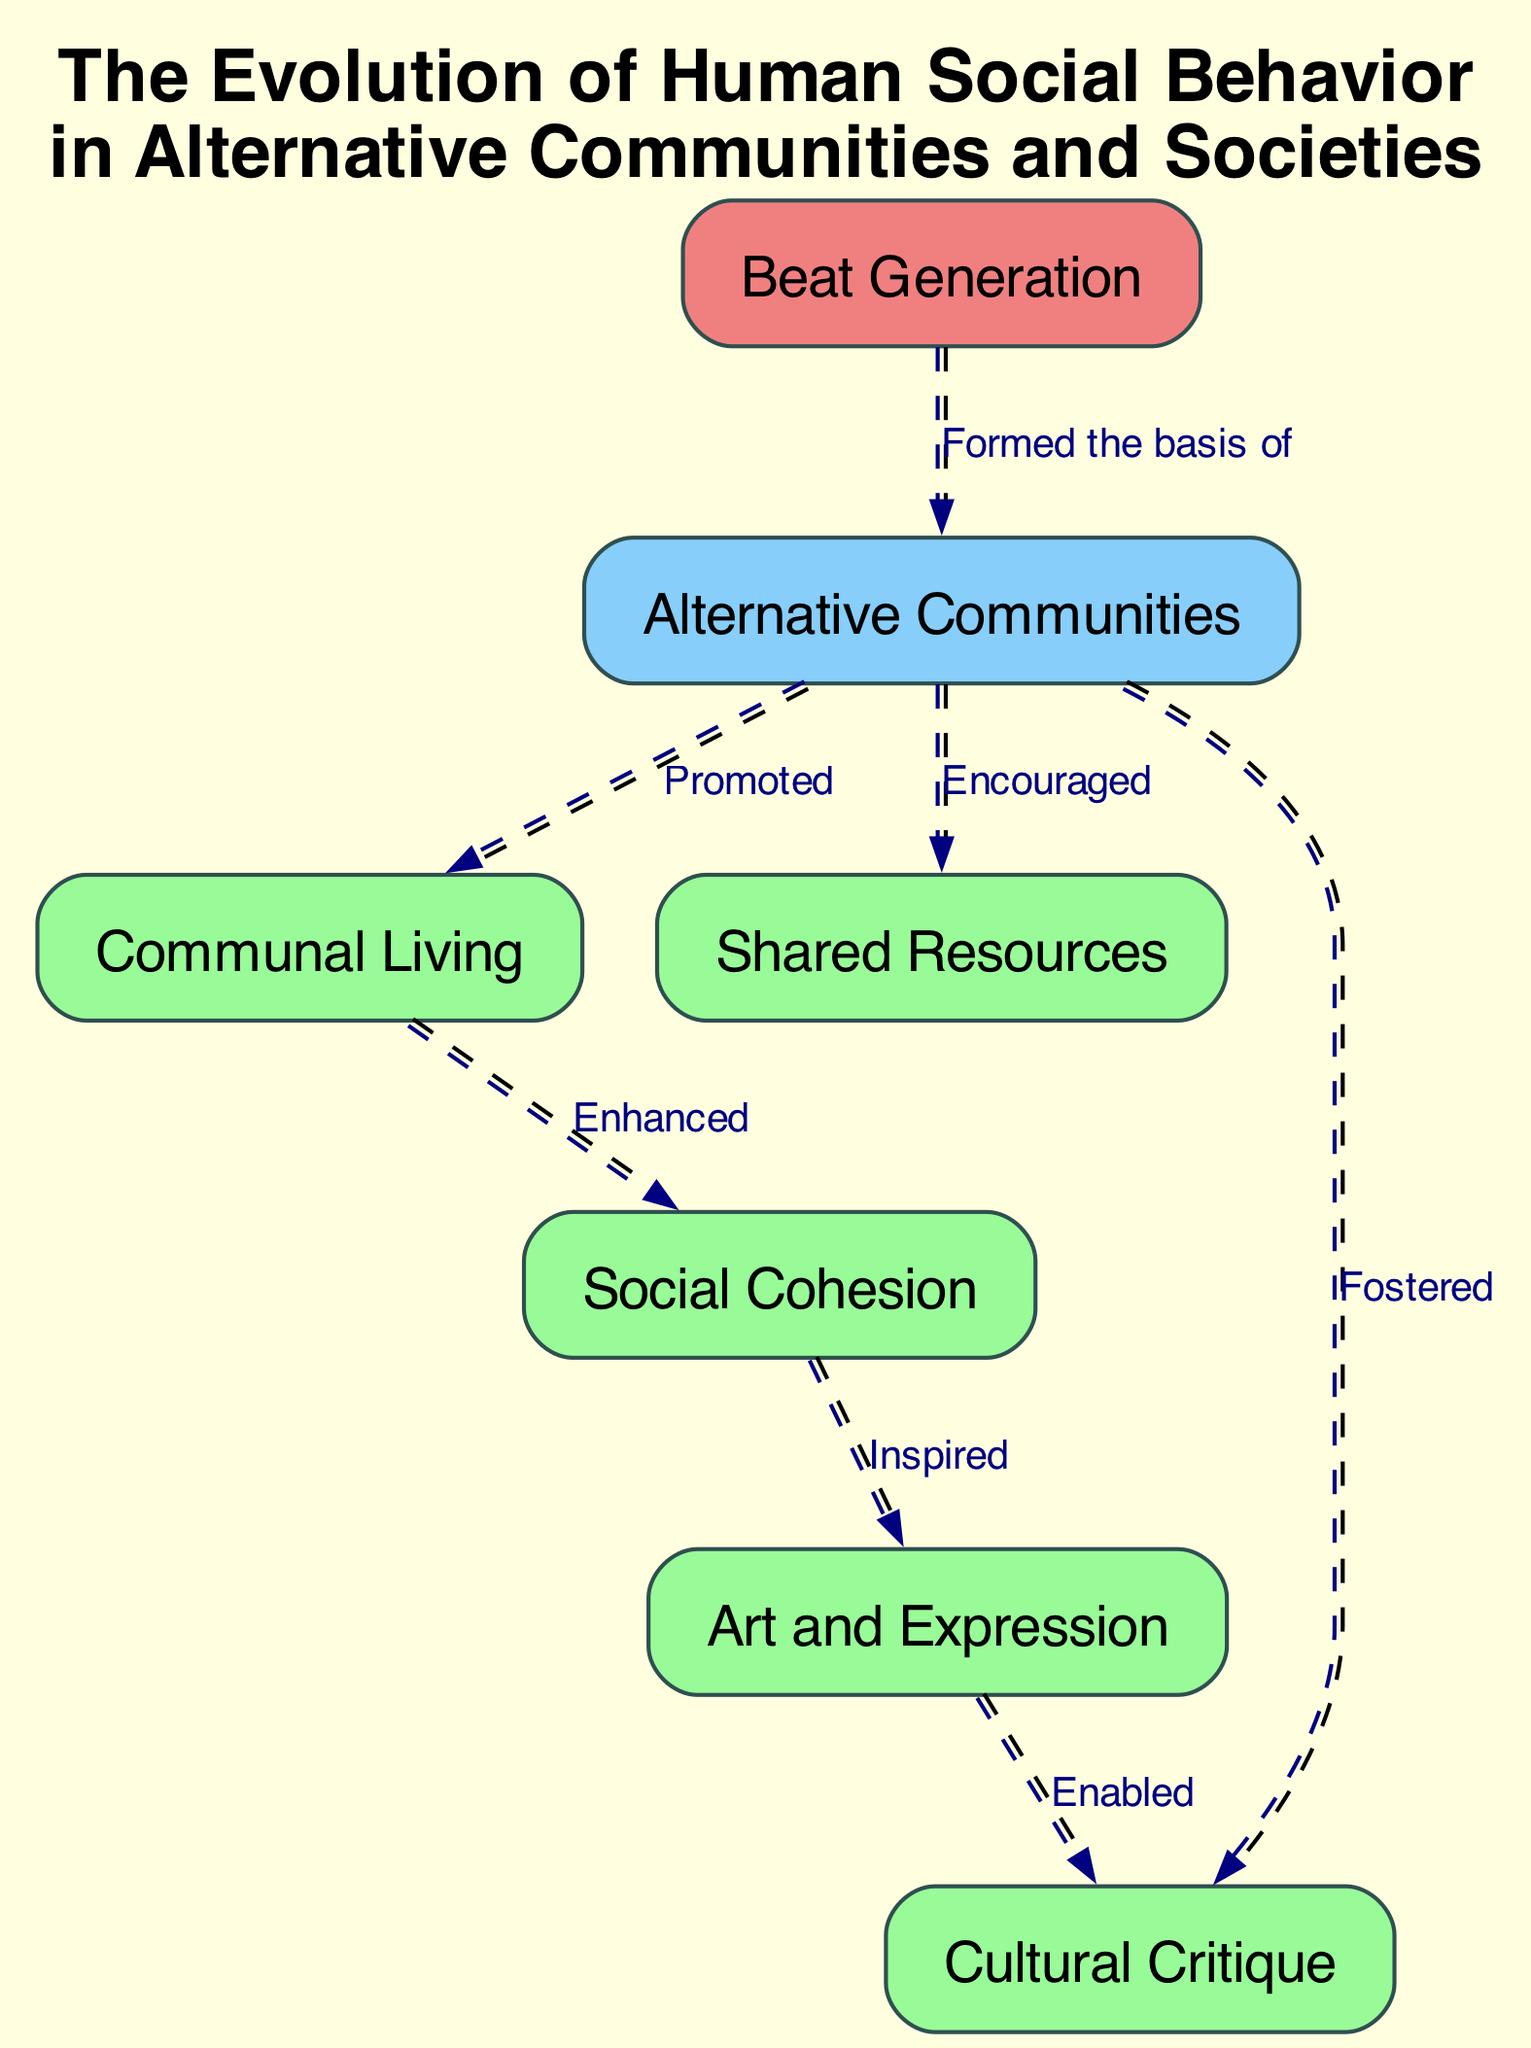What is the primary focus of the diagram? The diagram illustrates the evolution of human social behavior in alternative communities and societies, highlighting the relationships between various elements in this context.
Answer: Evolution of human social behavior How many nodes are present in the diagram? By counting each unique label represented in the diagram, we can see that there are seven distinct nodes, indicating different concepts related to the subject matter.
Answer: 7 What label is associated with the edge from "Beat Generation" to "Alternative Communities"? The edge directly linking these two nodes is labeled "Formed the basis of," indicating the foundational impact of the Beat Generation on alternative communities.
Answer: Formed the basis of What type of living is promoted by "Alternative Communities"? The diagram shows that "Alternative Communities" promotes "Communal Living," evidencing a focus on shared lifestyles and collaboration within such groups.
Answer: Communal Living Which node is enabled by "Art and Expression"? The diagram indicates that "Art and Expression" enables "Cultural Critique," suggesting a connection where artistic expression fosters critical examination of culture.
Answer: Cultural Critique How does "Communal Living" affect "Social Cohesion"? The diagram illustrates that "Communal Living" enhances "Social Cohesion," which reflects the idea that living together in a community strengthens bonds among individuals.
Answer: Enhanced What relationship exists between "Social Cohesion" and "Art and Expression"? The diagram shows that "Social Cohesion" is inspired by "Art and Expression," implying that creative expression fosters social unity and togetherness in communities.
Answer: Inspired What do "Shared Resources" and "Cultural Critique" have in common through their connection? Both "Shared Resources" and "Cultural Critique" reflect facets of alternative communities, but the specific edge shows that through these connections, resources might underlie critical cultural discussions.
Answer: Fostered Which specific node has a special style in the diagram? In the diagram, "Beat Generation" is uniquely styled with a light coral fill, distinguishing it from the other nodes and emphasizing its importance in this social context.
Answer: Beat Generation 